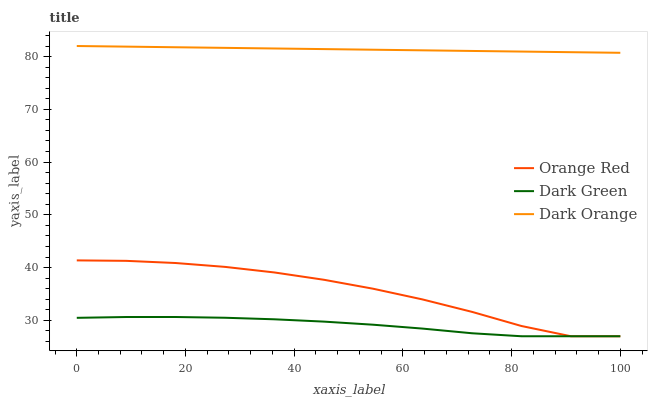Does Dark Green have the minimum area under the curve?
Answer yes or no. Yes. Does Dark Orange have the maximum area under the curve?
Answer yes or no. Yes. Does Orange Red have the minimum area under the curve?
Answer yes or no. No. Does Orange Red have the maximum area under the curve?
Answer yes or no. No. Is Dark Orange the smoothest?
Answer yes or no. Yes. Is Orange Red the roughest?
Answer yes or no. Yes. Is Dark Green the smoothest?
Answer yes or no. No. Is Dark Green the roughest?
Answer yes or no. No. Does Orange Red have the lowest value?
Answer yes or no. Yes. Does Dark Orange have the highest value?
Answer yes or no. Yes. Does Orange Red have the highest value?
Answer yes or no. No. Is Dark Green less than Dark Orange?
Answer yes or no. Yes. Is Dark Orange greater than Dark Green?
Answer yes or no. Yes. Does Orange Red intersect Dark Green?
Answer yes or no. Yes. Is Orange Red less than Dark Green?
Answer yes or no. No. Is Orange Red greater than Dark Green?
Answer yes or no. No. Does Dark Green intersect Dark Orange?
Answer yes or no. No. 